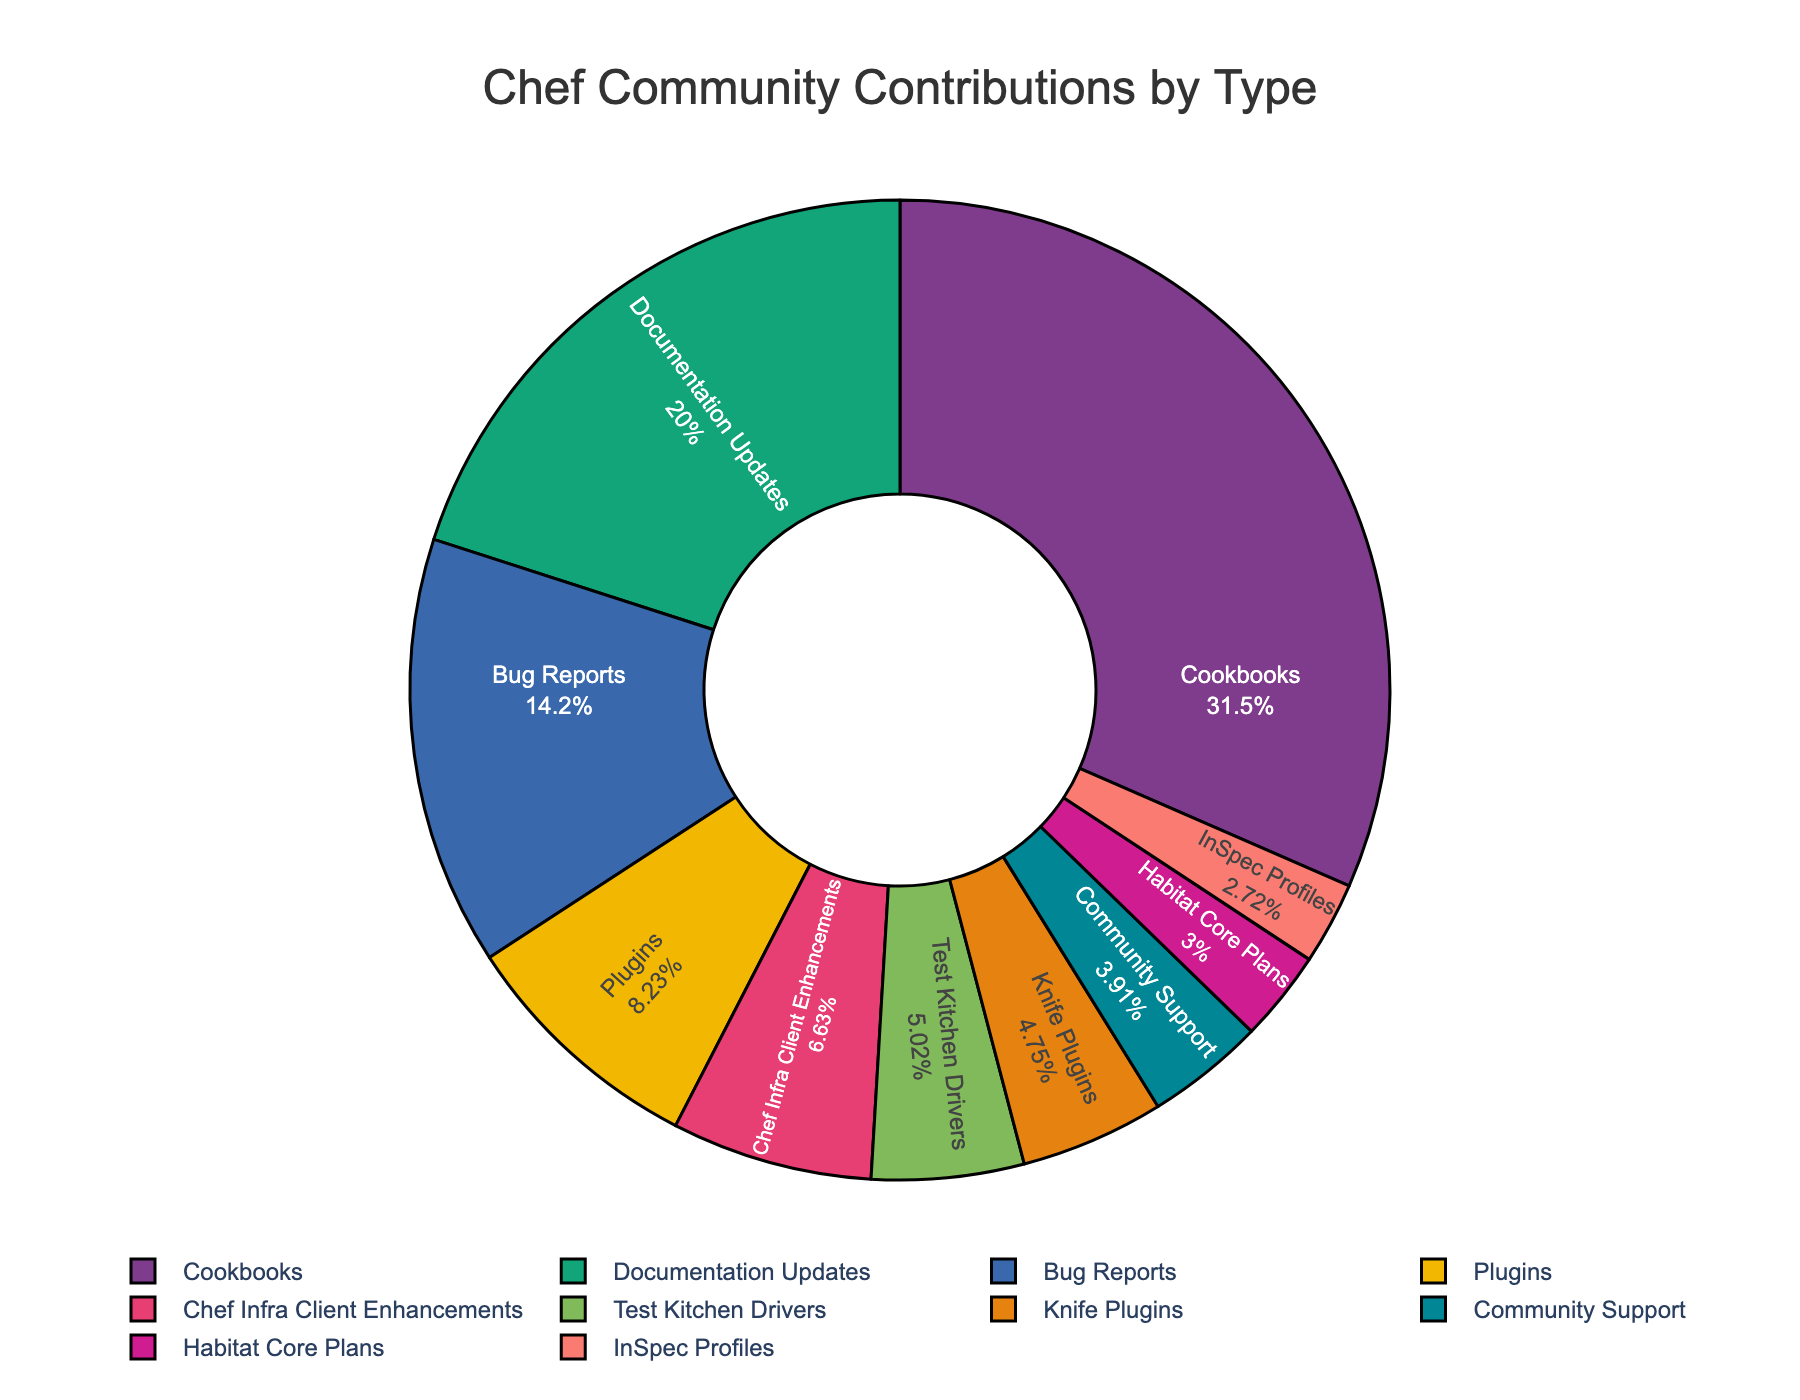How many more contributions are there for Cookbooks than for Plugins? To determine this, subtract the number of Plugin contributions from the number of Cookbook contributions. Cookbooks have 452 contributions, and Plugins have 118 contributions. So, 452 - 118 = 334.
Answer: 334 Which category has the highest number of contributions? By visually analyzing the pie chart, identify which segment is the largest. The largest segment corresponds to Cookbooks.
Answer: Cookbooks What percentage of contributions does Documentation Updates make up? To find the percentage, look at the pie chart segment for Documentation Updates. It typically displays the value in percentage inside the slice. According to the data provided, Documentation Updates has 287 contributions out of a total of 1433 contributions. This is approximately (287/1433)*100 ≈ 20.02%.
Answer: ~20% Are there more contributions in Documentation Updates or Bug Reports? Compare the size of the segments for Documentation Updates and Bug Reports in the pie chart. Documentation Updates have 287 contributions, whereas Bug Reports have 203 contributions.
Answer: Documentation Updates What is the combined percentage of contributions for Plugins and Chef Infra Client Enhancements? Add the contributions of Plugins (118) and Chef Infra Client Enhancements (95) to get a combined contribution of 213. The total number of contributions is 1433. Therefore, the combined percentage is (213/1433)*100 ≈ 14.87%.
Answer: ~14.87% Which category has the smallest number of contributions? Identify the smallest segment in the pie chart. The smallest segment corresponds to InSpec Profiles.
Answer: InSpec Profiles How much larger is the number of contributions to Community Support than Habitat Core Plans? Subtract the number of Habitat Core Plans contributions (43) from the number of Community Support contributions (56). So, 56 - 43 = 13.
Answer: 13 What is the percentage difference between Knife Plugins and Test Kitchen Drivers contributions? Calculate the percentage difference using the formula: ((Difference in contributions) / (Average of contributions))*100. For Knife Plugins (68) and Test Kitchen Drivers (72), the difference is 72 - 68 = 4, and the average is (68 + 72)/2 = 70. So, the percentage difference is (4/70)*100 ≈ 5.71%.
Answer: ~5.71% How does the percentage contribution of Cookbooks compare to the total contributions of Bug Reports and Plugins? Determine the percentage of Cookbooks by (452/1433)*100 ≈ 31.54%, then calculate the combined percentage of Bug Reports (203) and Plugins (118), which is (321/1433)*100 ≈ 22.40%. Cookbooks' percentage is higher.
Answer: Cookbooks' percentage is higher If you combine the contributions of Test Kitchen Drivers and Knife Plugins, where would this combined value place in the ranking of contributions? First, sum up the contributions for Test Kitchen Drivers (72) and Knife Plugins (68) to get 140. Rank this sum against the provided data: Cookbooks (452), Documentation Updates (287), Bug Reports (203), Plugins (118). 140 would place fifth overall, after Plugins.
Answer: Fifth overall 